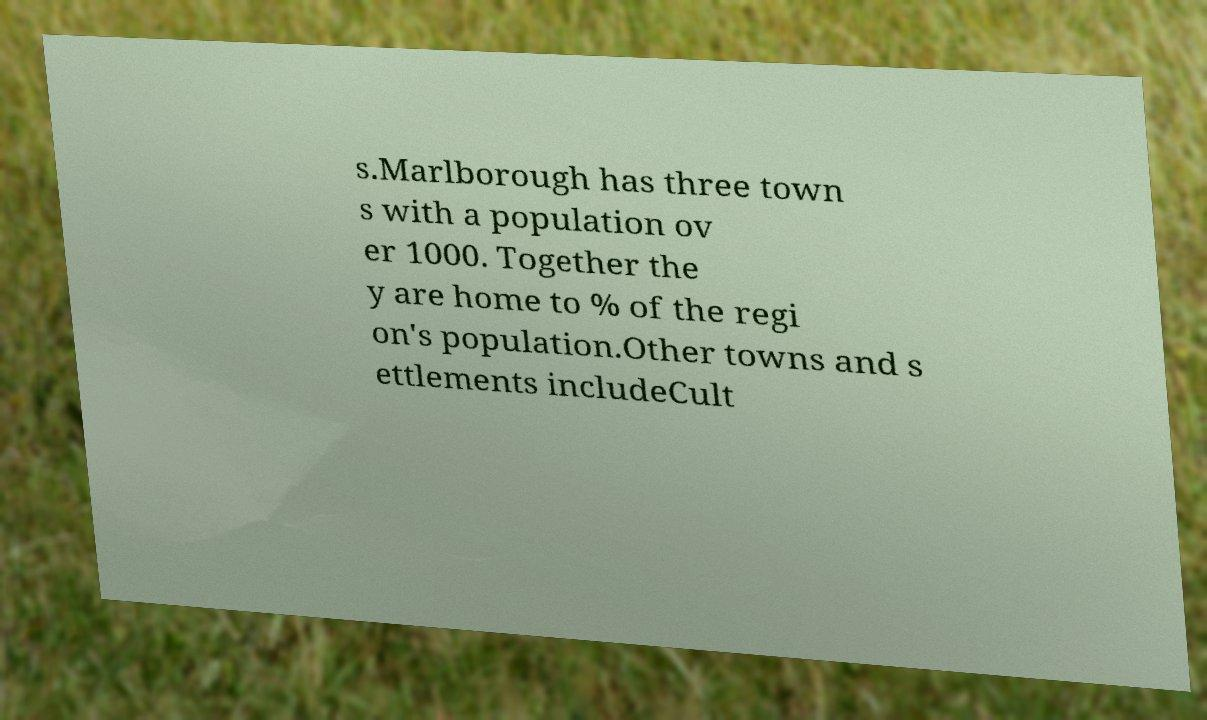Could you extract and type out the text from this image? s.Marlborough has three town s with a population ov er 1000. Together the y are home to % of the regi on's population.Other towns and s ettlements includeCult 